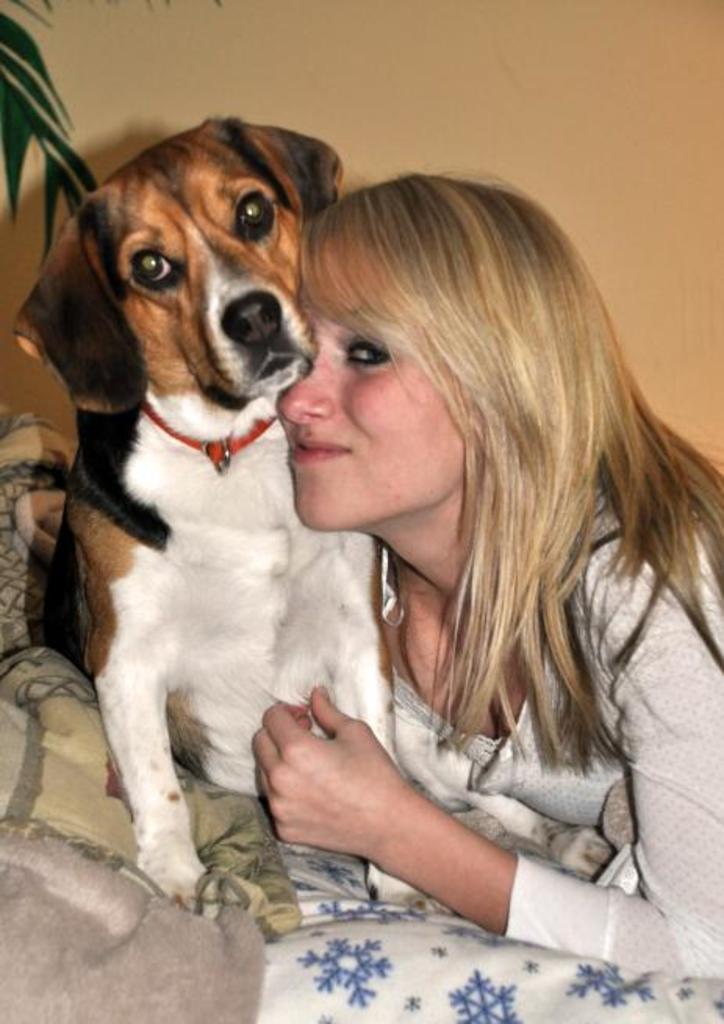Please provide a concise description of this image. There is a woman holding a dog in a fur blanket. 